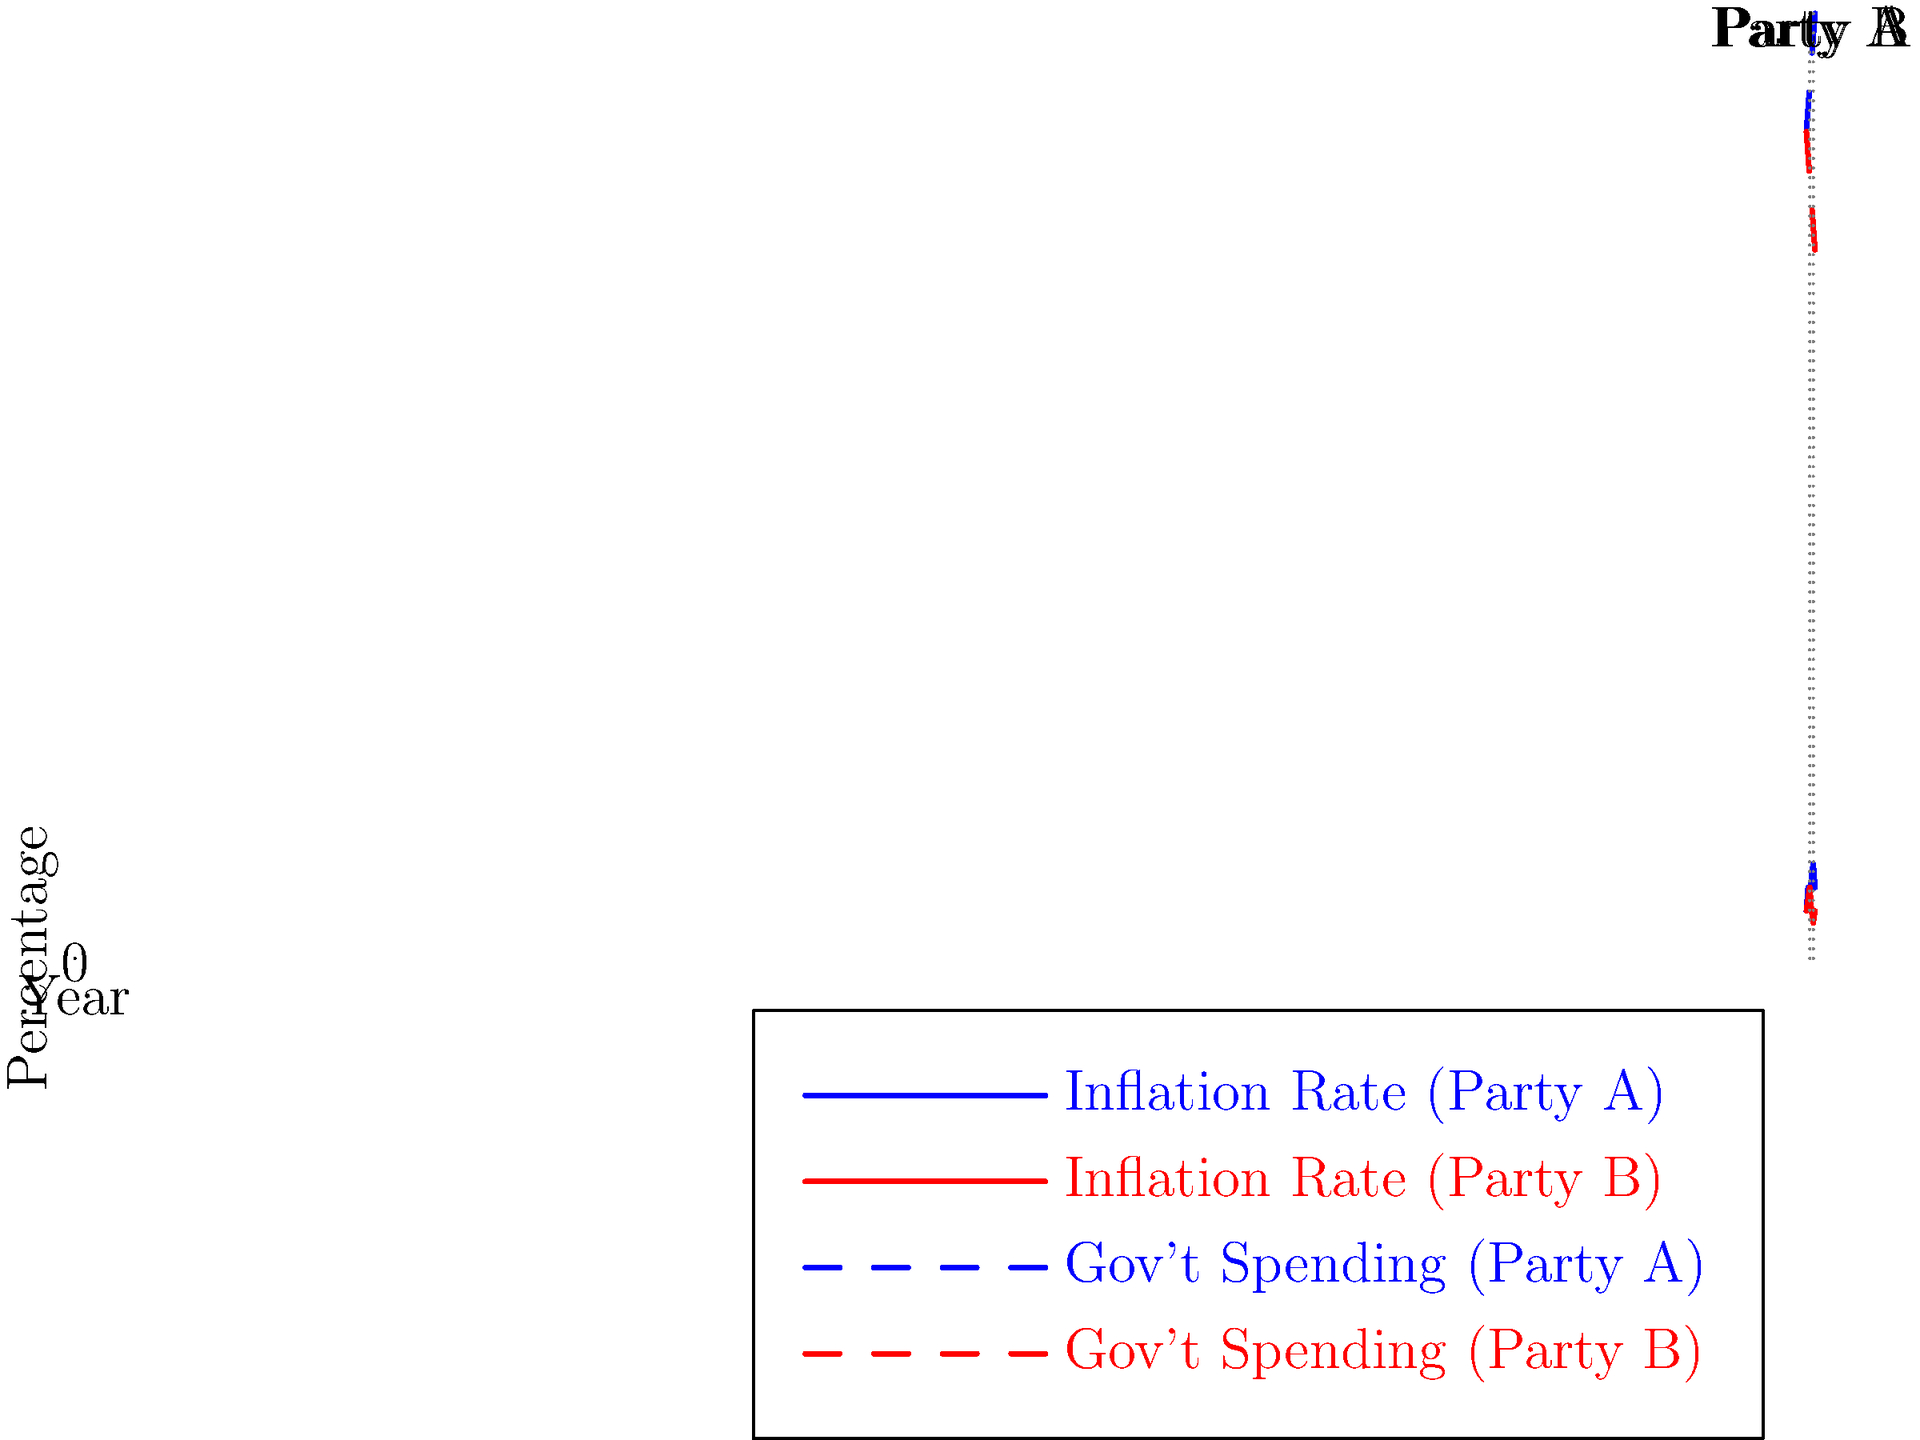Based on the multi-line graph showing inflation rates and government spending across different political regimes from 2010 to 2020, what relationship can be inferred between a party's approach to government spending and its impact on inflation rates? How does this align with or challenge traditional macroeconomic theories? To answer this question, we need to analyze the graph step-by-step:

1. Identify the regimes:
   - Party A: 2010-2014 and 2018-2020
   - Party B: 2014-2018

2. Analyze government spending trends:
   - Party A: Increasing trend (from 35% to 40% of GDP)
   - Party B: Decreasing trend (from 35% to 30% of GDP)

3. Analyze inflation rate trends:
   - Party A: Generally higher and more volatile (ranging from 2% to 4%)
   - Party B: Generally lower and more stable (ranging from 1.5% to 3%)

4. Identify the relationship:
   - Party A's increasing government spending correlates with higher and more volatile inflation rates
   - Party B's decreasing government spending correlates with lower and more stable inflation rates

5. Compare with traditional macroeconomic theories:
   - Keynesian theory suggests that increased government spending can stimulate economic growth but may lead to higher inflation
   - Monetarist theory emphasizes that excessive money supply growth (often due to increased government spending) leads to inflation

6. Interpret the results:
   - The data aligns with both Keynesian and Monetarist theories
   - Party A's approach (higher spending) seems to lead to higher inflation, consistent with both theories
   - Party B's approach (lower spending) seems to lead to lower inflation, also consistent with both theories

7. Consider limitations:
   - Correlation does not imply causation
   - Other factors not shown in the graph may influence inflation rates
   - The time frame is relatively short, and longer-term trends might reveal different patterns
Answer: The graph suggests a positive correlation between government spending and inflation rates, aligning with both Keynesian and Monetarist theories. However, other factors and longer-term trends should be considered for a comprehensive analysis. 